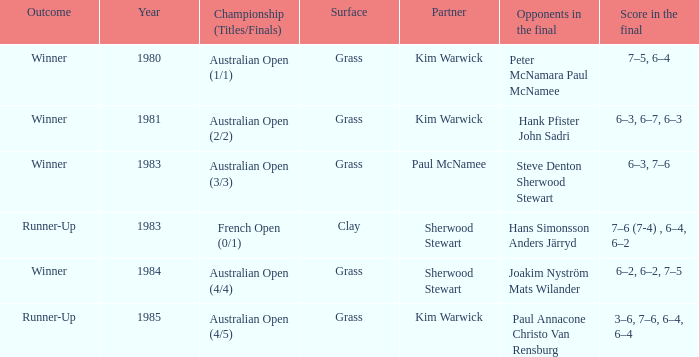How many different outcomes did the final with Paul McNamee as a partner have? 1.0. 